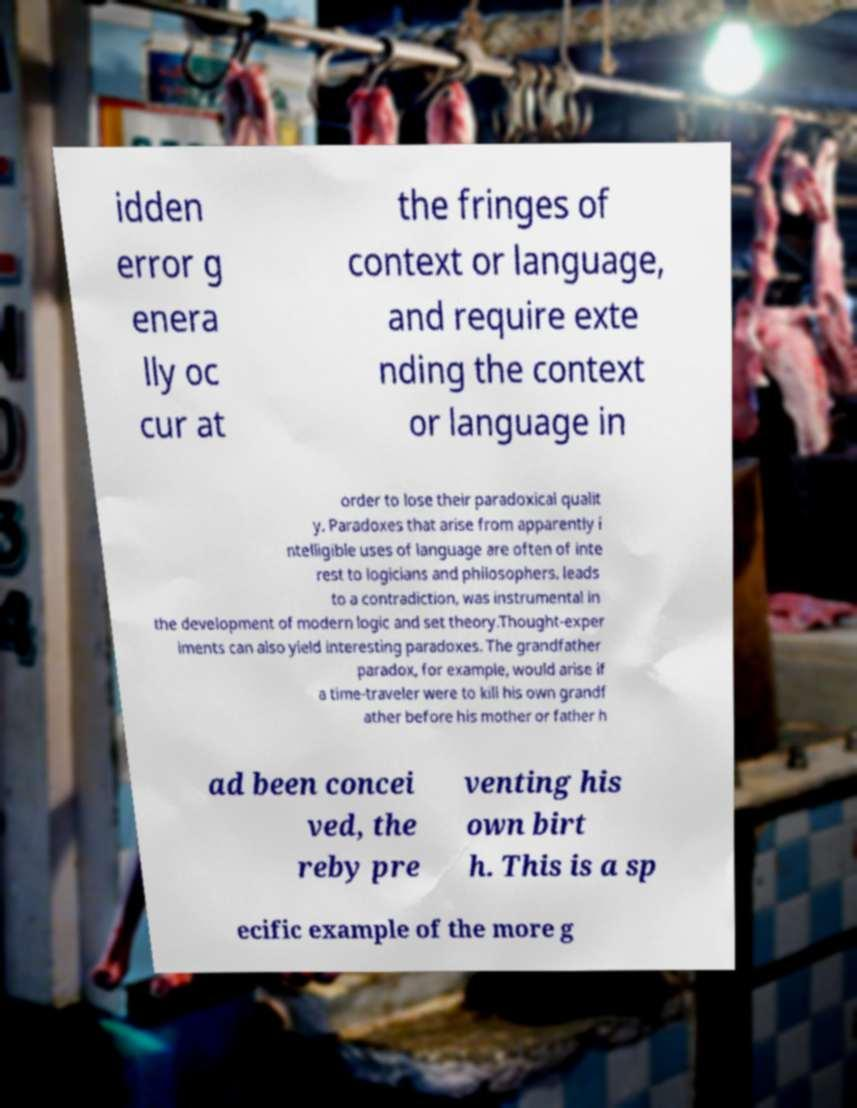Please identify and transcribe the text found in this image. idden error g enera lly oc cur at the fringes of context or language, and require exte nding the context or language in order to lose their paradoxical qualit y. Paradoxes that arise from apparently i ntelligible uses of language are often of inte rest to logicians and philosophers. leads to a contradiction, was instrumental in the development of modern logic and set theory.Thought-exper iments can also yield interesting paradoxes. The grandfather paradox, for example, would arise if a time-traveler were to kill his own grandf ather before his mother or father h ad been concei ved, the reby pre venting his own birt h. This is a sp ecific example of the more g 